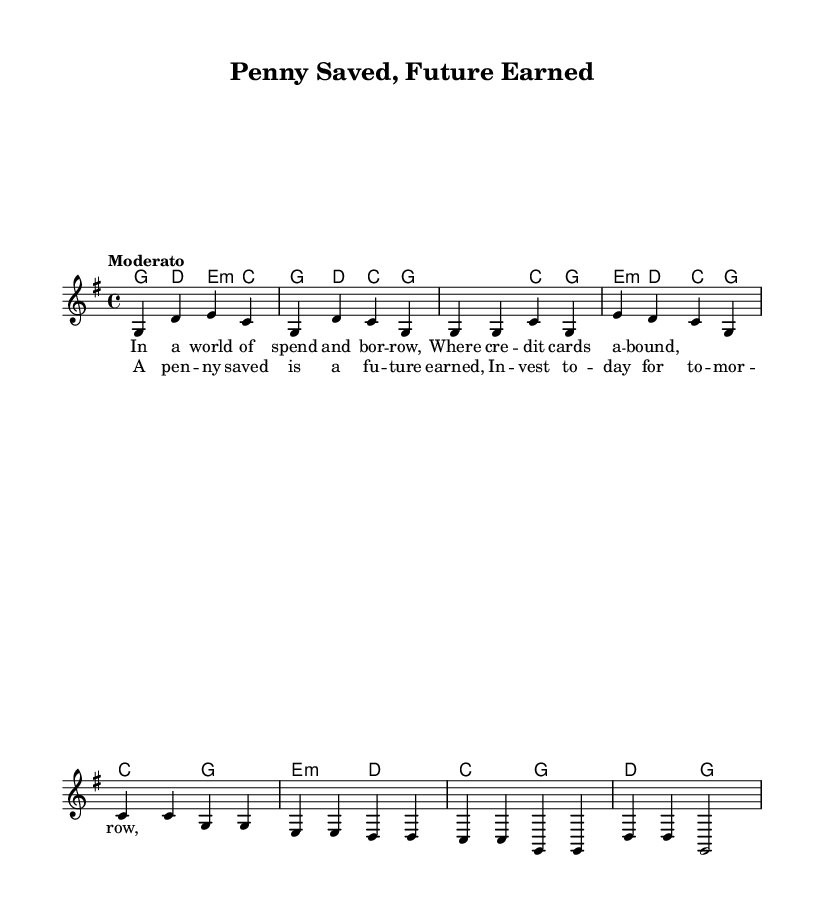What is the key signature of this music? The key signature indicates that this piece is in G major, which has one sharp (F#). This is evident from the global settings specified at the beginning of the code.
Answer: G major What is the time signature of this music? The time signature is found in the global section and specifies that there are four beats per measure, indicated by the "4/4" notation.
Answer: 4/4 What is the tempo marking for this music? The tempo marking is indicated as "Moderato," which refers to a moderately paced tempo. This can be identified in the global section of the provided code.
Answer: Moderato What is the title of this piece? The title is specified in the header section of the code, and it reflects the main theme of the song.
Answer: Penny Saved, Future Earned How many measures does the chorus contain? To determine this, we can count the measures specifically labeled as the chorus. There are four measures in the chorus section of the melody and harmony lines combined.
Answer: 4 What is the main theme or message conveyed in the chorus lyrics? Analyzing the lyrics provided in the chorus, the main theme focuses on saving money and investing for a brighter future, emphasizing the importance of financial responsibility.
Answer: Saving and investing What chord is used in the last measure of the chorus? The chord used in the last measure of the chorus is indicated as a "G" chord, defined in the harmonies section of the code. This is confirmed by the corresponding notes in the melody.
Answer: G 